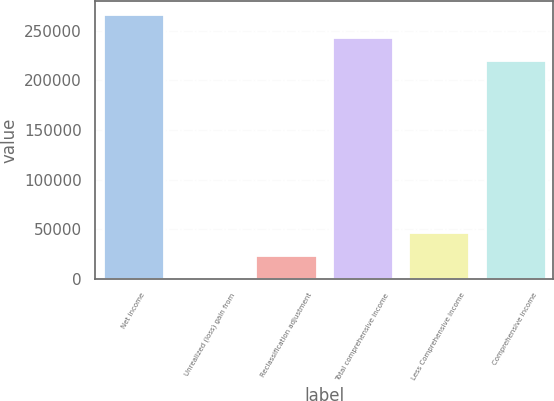Convert chart to OTSL. <chart><loc_0><loc_0><loc_500><loc_500><bar_chart><fcel>Net income<fcel>Unrealized (loss) gain from<fcel>Reclassification adjustment<fcel>Total comprehensive income<fcel>Less Comprehensive income<fcel>Comprehensive income<nl><fcel>266351<fcel>751<fcel>23778.1<fcel>243324<fcel>46805.2<fcel>220297<nl></chart> 